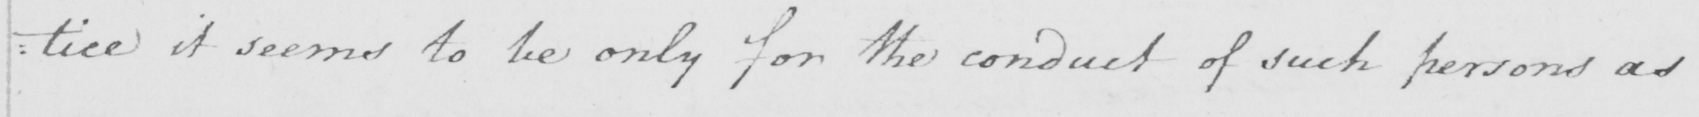What text is written in this handwritten line? : tice it seems to be only for the conduct of such persons as 